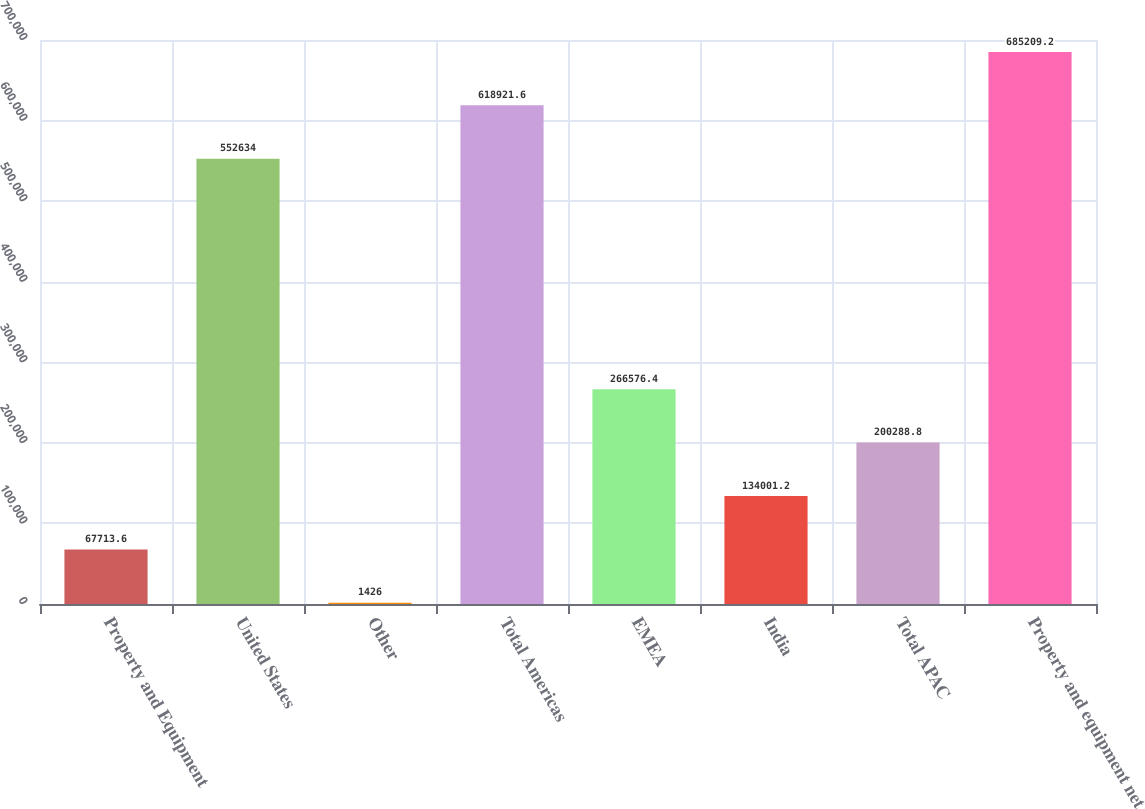Convert chart. <chart><loc_0><loc_0><loc_500><loc_500><bar_chart><fcel>Property and Equipment<fcel>United States<fcel>Other<fcel>Total Americas<fcel>EMEA<fcel>India<fcel>Total APAC<fcel>Property and equipment net<nl><fcel>67713.6<fcel>552634<fcel>1426<fcel>618922<fcel>266576<fcel>134001<fcel>200289<fcel>685209<nl></chart> 